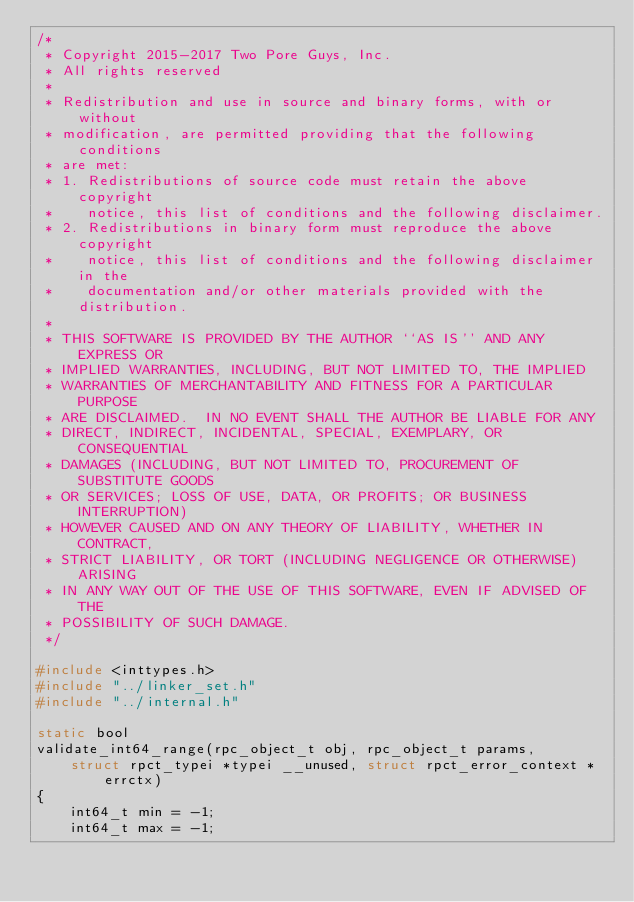<code> <loc_0><loc_0><loc_500><loc_500><_C_>/*
 * Copyright 2015-2017 Two Pore Guys, Inc.
 * All rights reserved
 *
 * Redistribution and use in source and binary forms, with or without
 * modification, are permitted providing that the following conditions
 * are met:
 * 1. Redistributions of source code must retain the above copyright
 *    notice, this list of conditions and the following disclaimer.
 * 2. Redistributions in binary form must reproduce the above copyright
 *    notice, this list of conditions and the following disclaimer in the
 *    documentation and/or other materials provided with the distribution.
 *
 * THIS SOFTWARE IS PROVIDED BY THE AUTHOR ``AS IS'' AND ANY EXPRESS OR
 * IMPLIED WARRANTIES, INCLUDING, BUT NOT LIMITED TO, THE IMPLIED
 * WARRANTIES OF MERCHANTABILITY AND FITNESS FOR A PARTICULAR PURPOSE
 * ARE DISCLAIMED.  IN NO EVENT SHALL THE AUTHOR BE LIABLE FOR ANY
 * DIRECT, INDIRECT, INCIDENTAL, SPECIAL, EXEMPLARY, OR CONSEQUENTIAL
 * DAMAGES (INCLUDING, BUT NOT LIMITED TO, PROCUREMENT OF SUBSTITUTE GOODS
 * OR SERVICES; LOSS OF USE, DATA, OR PROFITS; OR BUSINESS INTERRUPTION)
 * HOWEVER CAUSED AND ON ANY THEORY OF LIABILITY, WHETHER IN CONTRACT,
 * STRICT LIABILITY, OR TORT (INCLUDING NEGLIGENCE OR OTHERWISE) ARISING
 * IN ANY WAY OUT OF THE USE OF THIS SOFTWARE, EVEN IF ADVISED OF THE
 * POSSIBILITY OF SUCH DAMAGE.
 */

#include <inttypes.h>
#include "../linker_set.h"
#include "../internal.h"

static bool
validate_int64_range(rpc_object_t obj, rpc_object_t params,
    struct rpct_typei *typei __unused, struct rpct_error_context *errctx)
{
	int64_t min = -1;
	int64_t max = -1;</code> 